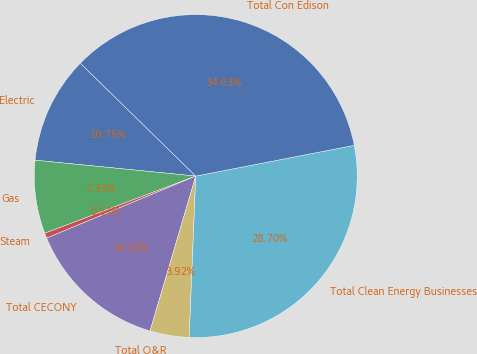Convert chart. <chart><loc_0><loc_0><loc_500><loc_500><pie_chart><fcel>Electric<fcel>Gas<fcel>Steam<fcel>Total CECONY<fcel>Total O&R<fcel>Total Clean Energy Businesses<fcel>Total Con Edison<nl><fcel>10.75%<fcel>7.33%<fcel>0.51%<fcel>14.16%<fcel>3.92%<fcel>28.7%<fcel>34.63%<nl></chart> 